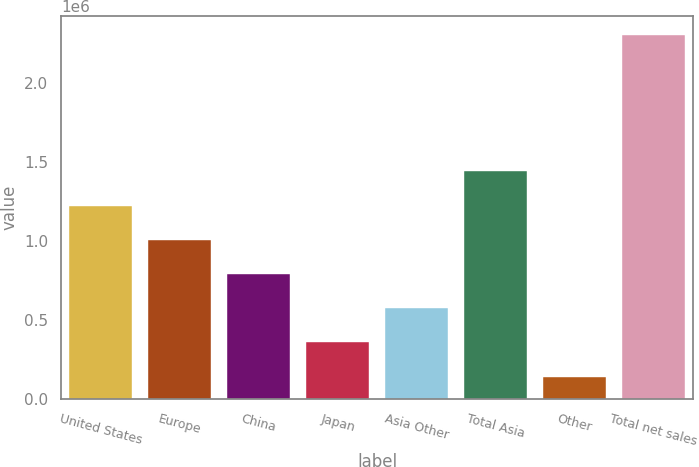Convert chart to OTSL. <chart><loc_0><loc_0><loc_500><loc_500><bar_chart><fcel>United States<fcel>Europe<fcel>China<fcel>Japan<fcel>Asia Other<fcel>Total Asia<fcel>Other<fcel>Total net sales<nl><fcel>1.2249e+06<fcel>1.00806e+06<fcel>791224<fcel>357551<fcel>574388<fcel>1.44173e+06<fcel>140715<fcel>2.30908e+06<nl></chart> 